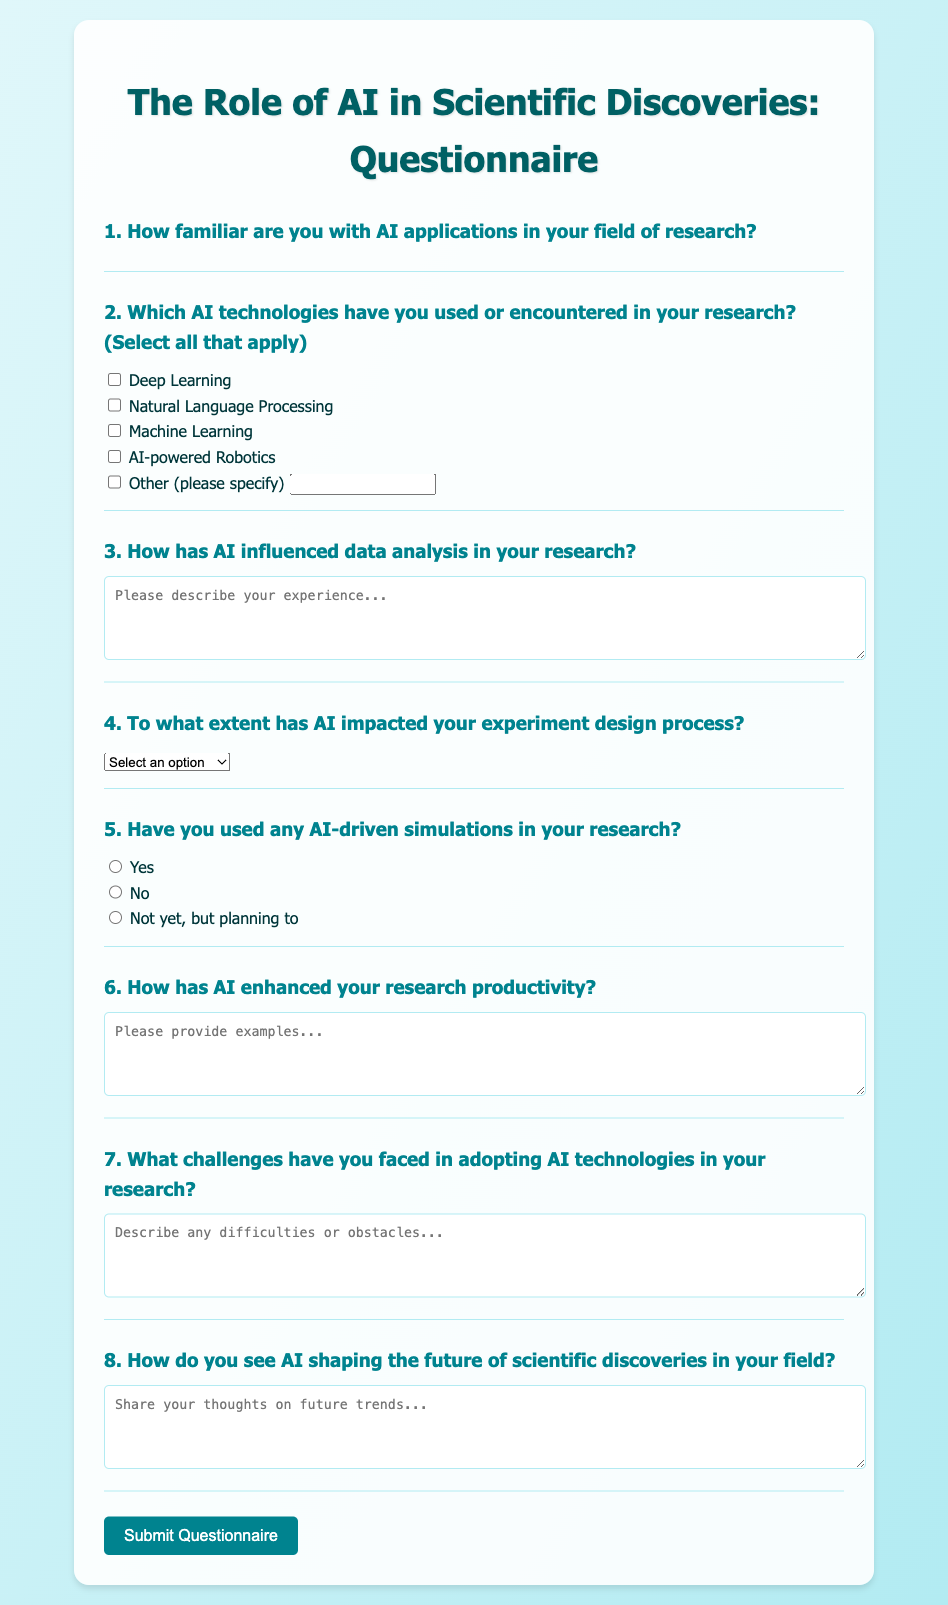What is the title of the questionnaire? The title of the questionnaire is provided at the top of the document.
Answer: The Role of AI in Scientific Discoveries: Questionnaire How many questions are there in the questionnaire? The document contains a list of questions provided in the form.
Answer: Eight questions Which AI technology is listed first in the checkbox options? The technologies are listed in order, with the first technology mentioned being the first checkbox.
Answer: Deep Learning What type of input is asked for question 3? This question specifically requests detailed user input in the form of text.
Answer: Textarea What is the rating scale used for familiarity with AI? The document indicates a rating system from 1 to 5, with each star representing a level of familiarity.
Answer: 1 to 5 Which option indicates a 'significant impact' on experiment design? The options for impact level contain specific descriptors, one of which denotes significant impact.
Answer: Significant impact What label is associated with the "Other" checkbox? The document provides a label that indicates users can input alternative technologies they encountered.
Answer: Other (please specify) What is the purpose of the submit button? The button is designed for submitting the responses collected in the questionnaire.
Answer: Submit Questionnaire 